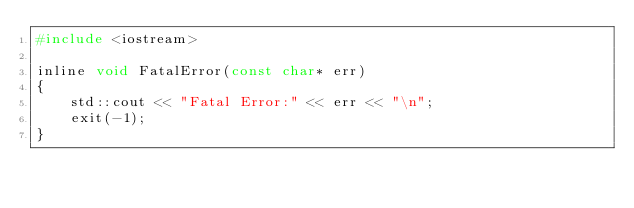Convert code to text. <code><loc_0><loc_0><loc_500><loc_500><_C_>#include <iostream>

inline void FatalError(const char* err)
{
    std::cout << "Fatal Error:" << err << "\n";
    exit(-1);
}</code> 